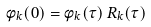<formula> <loc_0><loc_0><loc_500><loc_500>\phi _ { k } ( 0 ) = \phi _ { k } ( \tau ) \, R _ { k } ( \tau )</formula> 